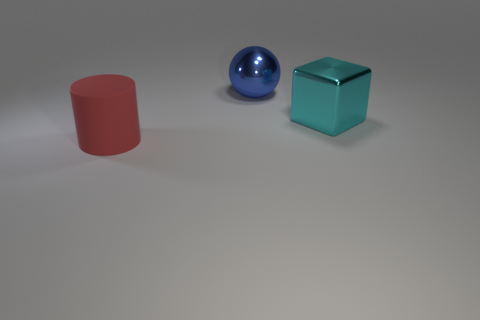Add 2 large gray rubber cylinders. How many objects exist? 5 Subtract all cylinders. How many objects are left? 2 Subtract all big shiny cubes. Subtract all cyan objects. How many objects are left? 1 Add 1 red matte cylinders. How many red matte cylinders are left? 2 Add 3 big spheres. How many big spheres exist? 4 Subtract 0 brown blocks. How many objects are left? 3 